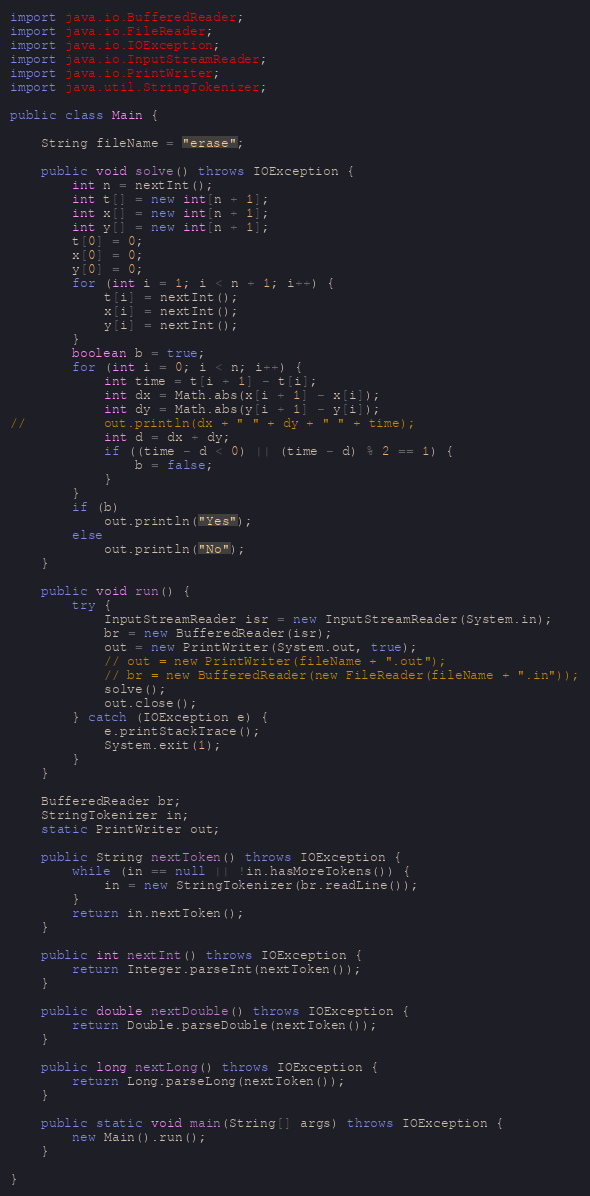<code> <loc_0><loc_0><loc_500><loc_500><_Java_>import java.io.BufferedReader;
import java.io.FileReader;
import java.io.IOException;
import java.io.InputStreamReader;
import java.io.PrintWriter;
import java.util.StringTokenizer;

public class Main {

	String fileName = "erase";

	public void solve() throws IOException {
		int n = nextInt();
		int t[] = new int[n + 1];
		int x[] = new int[n + 1];
		int y[] = new int[n + 1];
		t[0] = 0;
		x[0] = 0;
		y[0] = 0;
		for (int i = 1; i < n + 1; i++) {
			t[i] = nextInt();
			x[i] = nextInt();
			y[i] = nextInt();
		}
		boolean b = true;
		for (int i = 0; i < n; i++) {
			int time = t[i + 1] - t[i];
			int dx = Math.abs(x[i + 1] - x[i]);
			int dy = Math.abs(y[i + 1] - y[i]);
//			out.println(dx + " " + dy + " " + time);
			int d = dx + dy;
			if ((time - d < 0) || (time - d) % 2 == 1) {
				b = false;
			}
		}
		if (b)
			out.println("Yes");
		else
			out.println("No");
	}

	public void run() {
		try {
			InputStreamReader isr = new InputStreamReader(System.in);
			br = new BufferedReader(isr);
			out = new PrintWriter(System.out, true);
			// out = new PrintWriter(fileName + ".out");
			// br = new BufferedReader(new FileReader(fileName + ".in"));
			solve();
			out.close();
		} catch (IOException e) {
			e.printStackTrace();
			System.exit(1);
		}
	}

	BufferedReader br;
	StringTokenizer in;
	static PrintWriter out;

	public String nextToken() throws IOException {
		while (in == null || !in.hasMoreTokens()) {
			in = new StringTokenizer(br.readLine());
		}
		return in.nextToken();
	}

	public int nextInt() throws IOException {
		return Integer.parseInt(nextToken());
	}

	public double nextDouble() throws IOException {
		return Double.parseDouble(nextToken());
	}

	public long nextLong() throws IOException {
		return Long.parseLong(nextToken());
	}

	public static void main(String[] args) throws IOException {
		new Main().run();
	}

}
</code> 